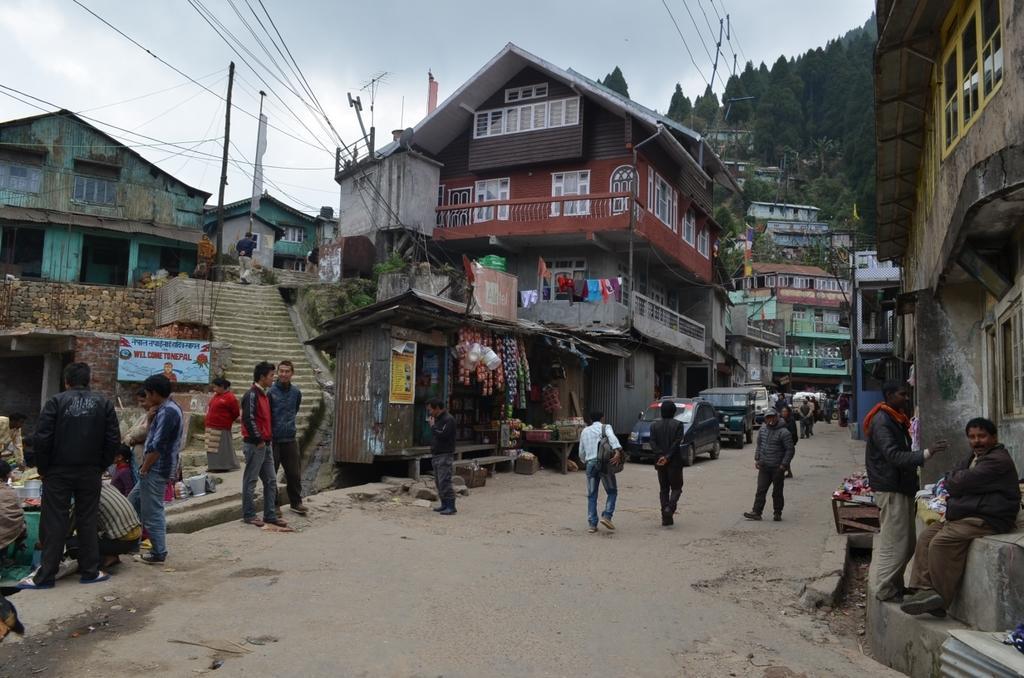Please provide a concise description of this image. On the left side, there are persons on the road. Beside them, there is a shop and there are steps. On the right side, there are persons and vehicles on the road and there are buildings. In the background, there are buildings, there is a mountain and there are clouds in the sky. 